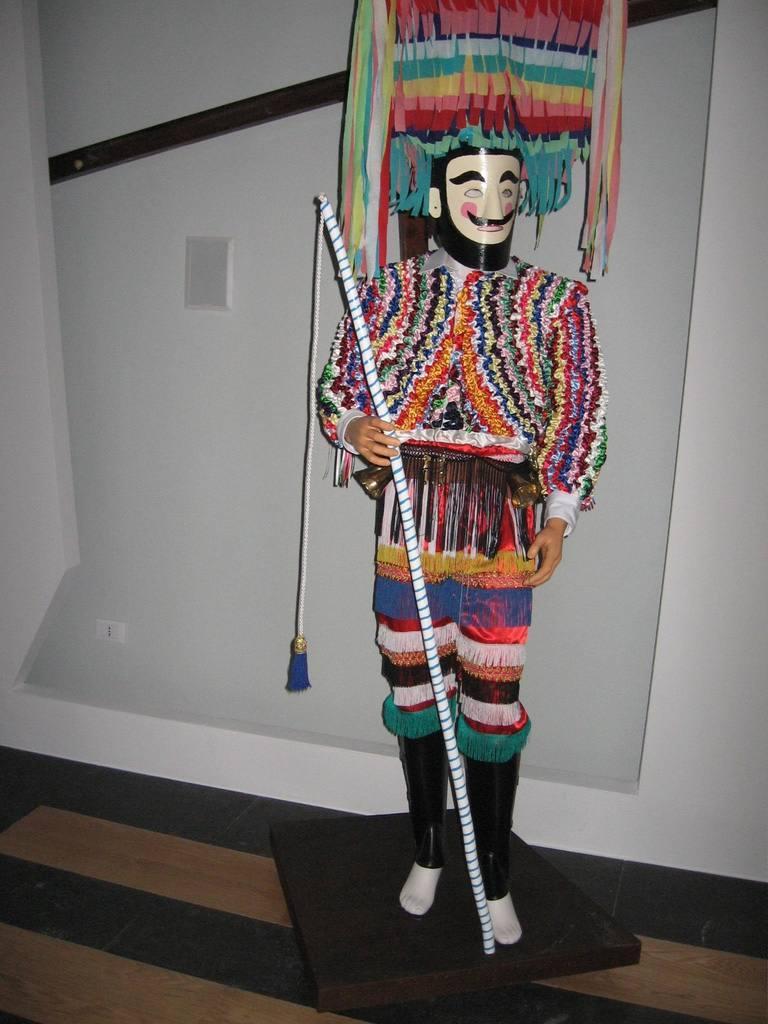Describe this image in one or two sentences. Here I can see a mannequin which is dressed with a costume and there is a stick in the hand. In the background there is a wall. At the bottom, I can see the floor. 